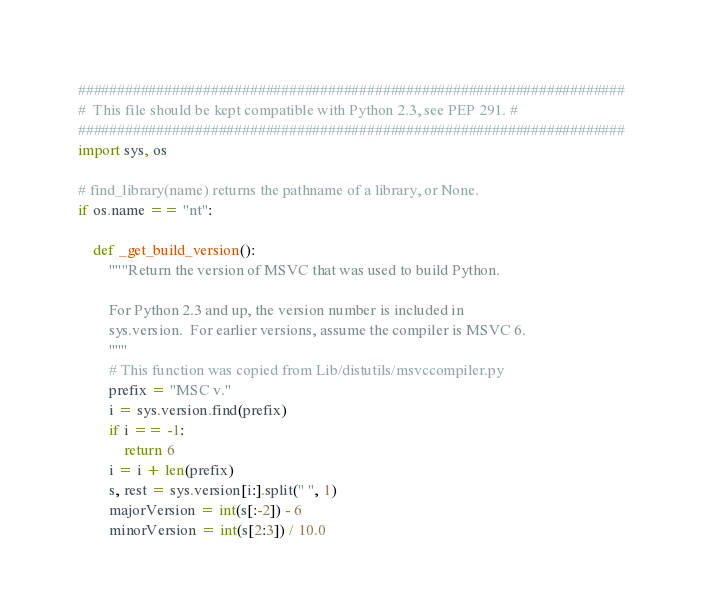<code> <loc_0><loc_0><loc_500><loc_500><_Python_>######################################################################
#  This file should be kept compatible with Python 2.3, see PEP 291. #
######################################################################
import sys, os

# find_library(name) returns the pathname of a library, or None.
if os.name == "nt":

    def _get_build_version():
        """Return the version of MSVC that was used to build Python.

        For Python 2.3 and up, the version number is included in
        sys.version.  For earlier versions, assume the compiler is MSVC 6.
        """
        # This function was copied from Lib/distutils/msvccompiler.py
        prefix = "MSC v."
        i = sys.version.find(prefix)
        if i == -1:
            return 6
        i = i + len(prefix)
        s, rest = sys.version[i:].split(" ", 1)
        majorVersion = int(s[:-2]) - 6
        minorVersion = int(s[2:3]) / 10.0</code> 